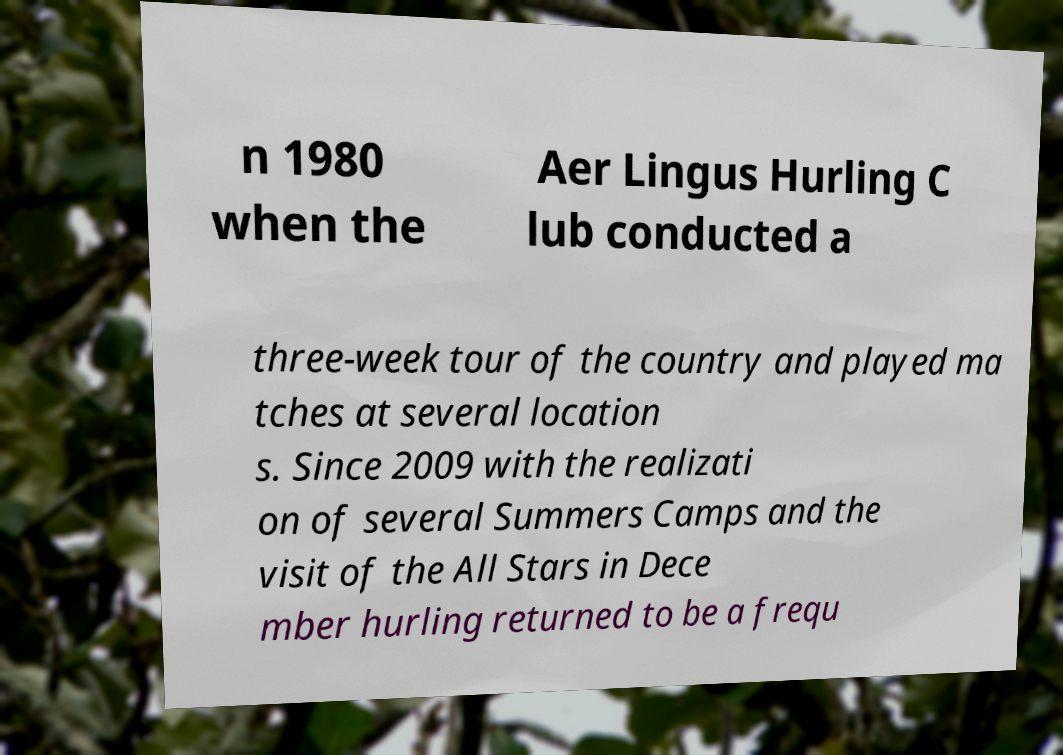Please identify and transcribe the text found in this image. n 1980 when the Aer Lingus Hurling C lub conducted a three-week tour of the country and played ma tches at several location s. Since 2009 with the realizati on of several Summers Camps and the visit of the All Stars in Dece mber hurling returned to be a frequ 